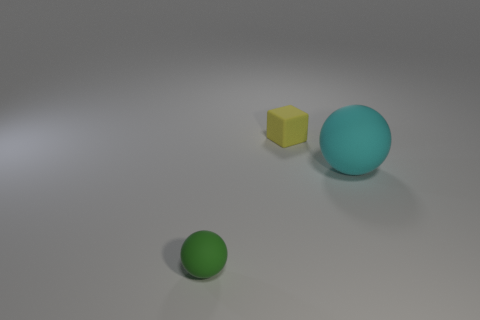Can you interpret the positioning of the objects in this scene? Sure, the placement appears deliberate, with the objects spaced out from one another. This arrangement might signify isolation or highlight individuality, especially considering the unique colors and varying sizes. Does the lighting suggest anything about the time or setting of this scene? The diffuse lighting with subtle shadows suggests an indoor setting, possibly in a studio environment. It doesn't give a clear indication of time but creates a neutral backdrop that focuses attention on the objects. 